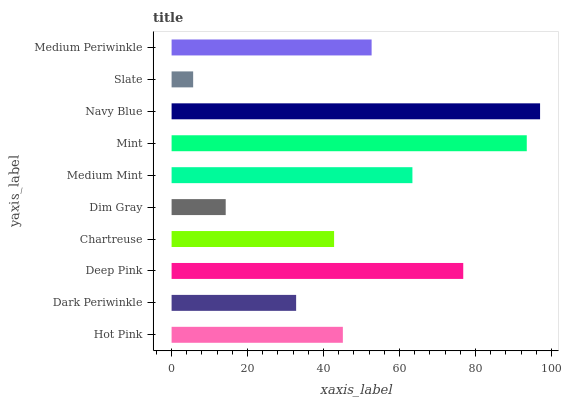Is Slate the minimum?
Answer yes or no. Yes. Is Navy Blue the maximum?
Answer yes or no. Yes. Is Dark Periwinkle the minimum?
Answer yes or no. No. Is Dark Periwinkle the maximum?
Answer yes or no. No. Is Hot Pink greater than Dark Periwinkle?
Answer yes or no. Yes. Is Dark Periwinkle less than Hot Pink?
Answer yes or no. Yes. Is Dark Periwinkle greater than Hot Pink?
Answer yes or no. No. Is Hot Pink less than Dark Periwinkle?
Answer yes or no. No. Is Medium Periwinkle the high median?
Answer yes or no. Yes. Is Hot Pink the low median?
Answer yes or no. Yes. Is Hot Pink the high median?
Answer yes or no. No. Is Chartreuse the low median?
Answer yes or no. No. 